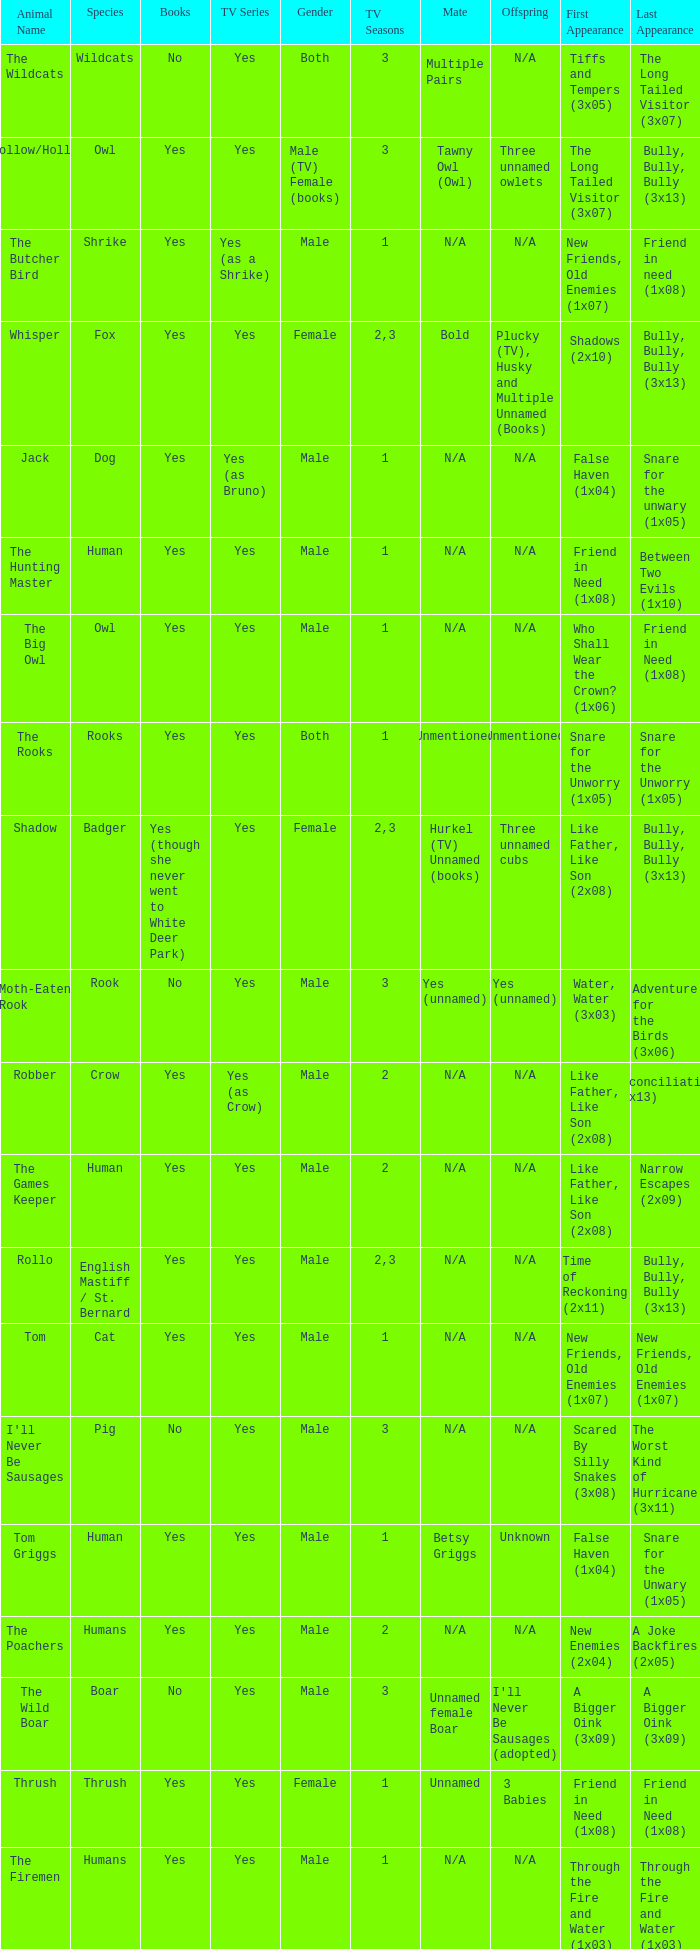What show has a boar? Yes. 